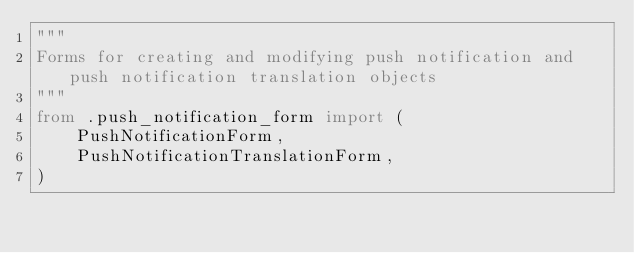<code> <loc_0><loc_0><loc_500><loc_500><_Python_>"""
Forms for creating and modifying push notification and push notification translation objects
"""
from .push_notification_form import (
    PushNotificationForm,
    PushNotificationTranslationForm,
)
</code> 